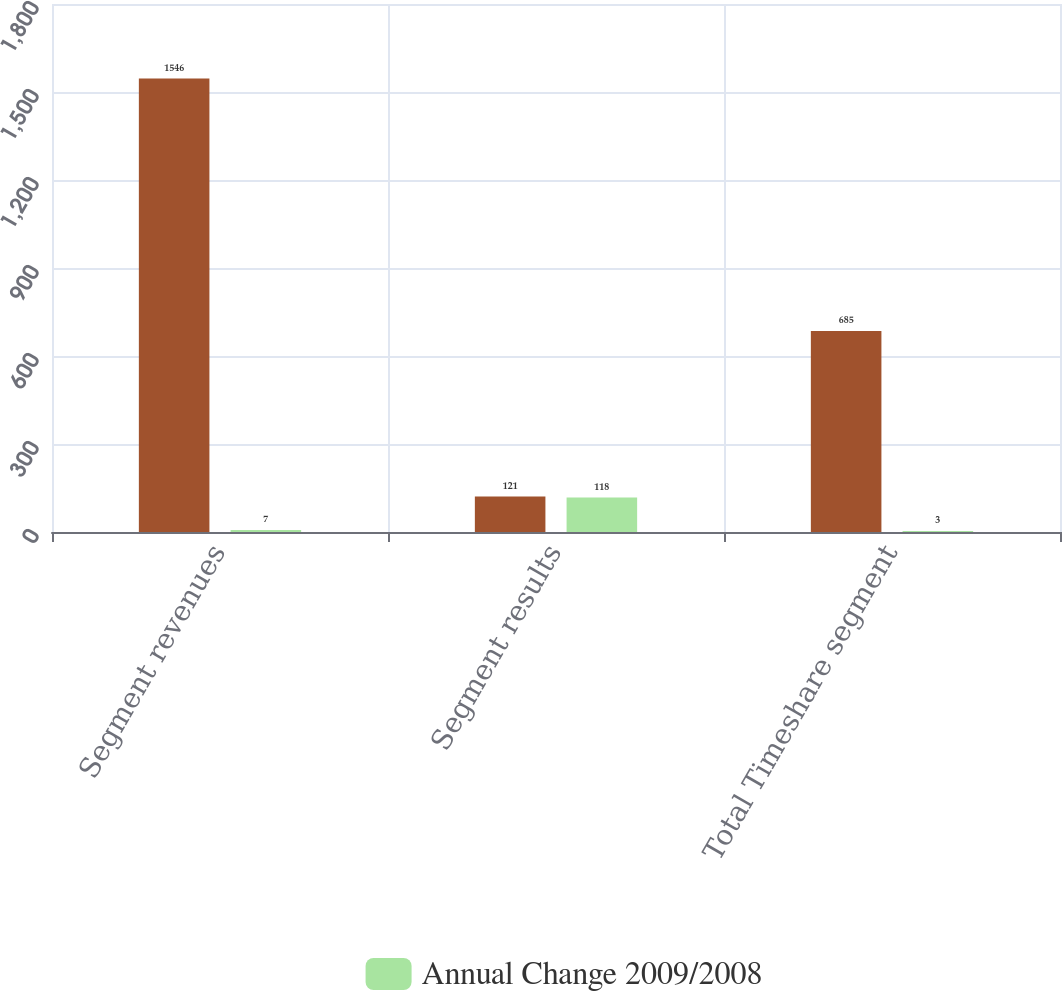Convert chart to OTSL. <chart><loc_0><loc_0><loc_500><loc_500><stacked_bar_chart><ecel><fcel>Segment revenues<fcel>Segment results<fcel>Total Timeshare segment<nl><fcel>nan<fcel>1546<fcel>121<fcel>685<nl><fcel>Annual Change 2009/2008<fcel>7<fcel>118<fcel>3<nl></chart> 